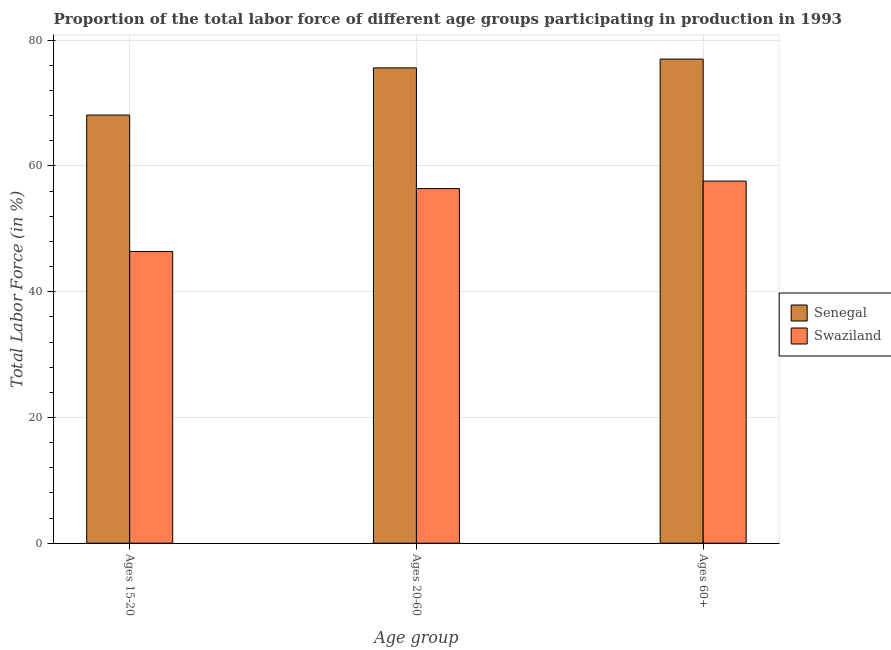How many different coloured bars are there?
Offer a very short reply. 2. How many groups of bars are there?
Provide a short and direct response. 3. Are the number of bars on each tick of the X-axis equal?
Provide a short and direct response. Yes. How many bars are there on the 1st tick from the right?
Your answer should be very brief. 2. What is the label of the 1st group of bars from the left?
Your answer should be very brief. Ages 15-20. What is the percentage of labor force within the age group 15-20 in Senegal?
Keep it short and to the point. 68.1. Across all countries, what is the maximum percentage of labor force within the age group 15-20?
Offer a very short reply. 68.1. Across all countries, what is the minimum percentage of labor force above age 60?
Make the answer very short. 57.6. In which country was the percentage of labor force within the age group 20-60 maximum?
Your response must be concise. Senegal. In which country was the percentage of labor force within the age group 20-60 minimum?
Provide a short and direct response. Swaziland. What is the total percentage of labor force within the age group 20-60 in the graph?
Your response must be concise. 132. What is the difference between the percentage of labor force above age 60 in Senegal and that in Swaziland?
Your response must be concise. 19.4. What is the difference between the percentage of labor force above age 60 in Senegal and the percentage of labor force within the age group 15-20 in Swaziland?
Your response must be concise. 30.6. What is the average percentage of labor force within the age group 20-60 per country?
Ensure brevity in your answer.  66. What is the difference between the percentage of labor force above age 60 and percentage of labor force within the age group 20-60 in Senegal?
Make the answer very short. 1.4. In how many countries, is the percentage of labor force within the age group 15-20 greater than 16 %?
Provide a succinct answer. 2. What is the ratio of the percentage of labor force within the age group 20-60 in Senegal to that in Swaziland?
Provide a succinct answer. 1.34. Is the percentage of labor force within the age group 20-60 in Swaziland less than that in Senegal?
Ensure brevity in your answer.  Yes. What is the difference between the highest and the second highest percentage of labor force within the age group 15-20?
Give a very brief answer. 21.7. What is the difference between the highest and the lowest percentage of labor force above age 60?
Offer a terse response. 19.4. In how many countries, is the percentage of labor force within the age group 15-20 greater than the average percentage of labor force within the age group 15-20 taken over all countries?
Keep it short and to the point. 1. What does the 1st bar from the left in Ages 60+ represents?
Offer a very short reply. Senegal. What does the 2nd bar from the right in Ages 15-20 represents?
Keep it short and to the point. Senegal. Is it the case that in every country, the sum of the percentage of labor force within the age group 15-20 and percentage of labor force within the age group 20-60 is greater than the percentage of labor force above age 60?
Keep it short and to the point. Yes. How many countries are there in the graph?
Provide a succinct answer. 2. What is the difference between two consecutive major ticks on the Y-axis?
Give a very brief answer. 20. Are the values on the major ticks of Y-axis written in scientific E-notation?
Your response must be concise. No. How are the legend labels stacked?
Offer a very short reply. Vertical. What is the title of the graph?
Provide a succinct answer. Proportion of the total labor force of different age groups participating in production in 1993. Does "Slovak Republic" appear as one of the legend labels in the graph?
Your answer should be compact. No. What is the label or title of the X-axis?
Your answer should be compact. Age group. What is the Total Labor Force (in %) of Senegal in Ages 15-20?
Ensure brevity in your answer.  68.1. What is the Total Labor Force (in %) of Swaziland in Ages 15-20?
Provide a succinct answer. 46.4. What is the Total Labor Force (in %) in Senegal in Ages 20-60?
Your response must be concise. 75.6. What is the Total Labor Force (in %) in Swaziland in Ages 20-60?
Give a very brief answer. 56.4. What is the Total Labor Force (in %) of Senegal in Ages 60+?
Make the answer very short. 77. What is the Total Labor Force (in %) of Swaziland in Ages 60+?
Your answer should be very brief. 57.6. Across all Age group, what is the maximum Total Labor Force (in %) of Senegal?
Your response must be concise. 77. Across all Age group, what is the maximum Total Labor Force (in %) in Swaziland?
Ensure brevity in your answer.  57.6. Across all Age group, what is the minimum Total Labor Force (in %) in Senegal?
Provide a succinct answer. 68.1. Across all Age group, what is the minimum Total Labor Force (in %) in Swaziland?
Your answer should be compact. 46.4. What is the total Total Labor Force (in %) of Senegal in the graph?
Give a very brief answer. 220.7. What is the total Total Labor Force (in %) in Swaziland in the graph?
Provide a short and direct response. 160.4. What is the difference between the Total Labor Force (in %) in Swaziland in Ages 15-20 and that in Ages 20-60?
Offer a terse response. -10. What is the difference between the Total Labor Force (in %) in Senegal in Ages 15-20 and that in Ages 60+?
Offer a very short reply. -8.9. What is the difference between the Total Labor Force (in %) in Senegal in Ages 20-60 and that in Ages 60+?
Offer a terse response. -1.4. What is the difference between the Total Labor Force (in %) in Senegal in Ages 15-20 and the Total Labor Force (in %) in Swaziland in Ages 20-60?
Provide a succinct answer. 11.7. What is the average Total Labor Force (in %) in Senegal per Age group?
Provide a short and direct response. 73.57. What is the average Total Labor Force (in %) of Swaziland per Age group?
Make the answer very short. 53.47. What is the difference between the Total Labor Force (in %) of Senegal and Total Labor Force (in %) of Swaziland in Ages 15-20?
Ensure brevity in your answer.  21.7. What is the ratio of the Total Labor Force (in %) in Senegal in Ages 15-20 to that in Ages 20-60?
Ensure brevity in your answer.  0.9. What is the ratio of the Total Labor Force (in %) in Swaziland in Ages 15-20 to that in Ages 20-60?
Your response must be concise. 0.82. What is the ratio of the Total Labor Force (in %) of Senegal in Ages 15-20 to that in Ages 60+?
Provide a short and direct response. 0.88. What is the ratio of the Total Labor Force (in %) of Swaziland in Ages 15-20 to that in Ages 60+?
Offer a very short reply. 0.81. What is the ratio of the Total Labor Force (in %) of Senegal in Ages 20-60 to that in Ages 60+?
Ensure brevity in your answer.  0.98. What is the ratio of the Total Labor Force (in %) of Swaziland in Ages 20-60 to that in Ages 60+?
Keep it short and to the point. 0.98. What is the difference between the highest and the second highest Total Labor Force (in %) in Senegal?
Give a very brief answer. 1.4. What is the difference between the highest and the second highest Total Labor Force (in %) of Swaziland?
Provide a short and direct response. 1.2. 